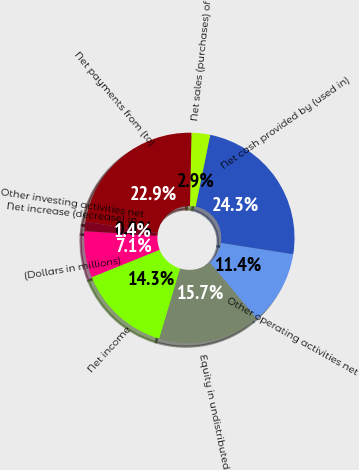<chart> <loc_0><loc_0><loc_500><loc_500><pie_chart><fcel>(Dollars in millions)<fcel>Net income<fcel>Equity in undistributed<fcel>Other operating activities net<fcel>Net cash provided by (used in)<fcel>Net sales (purchases) of<fcel>Net payments from (to)<fcel>Other investing activities net<fcel>Net increase (decrease) in<nl><fcel>7.14%<fcel>14.29%<fcel>15.71%<fcel>11.43%<fcel>24.29%<fcel>2.86%<fcel>22.86%<fcel>0.0%<fcel>1.43%<nl></chart> 